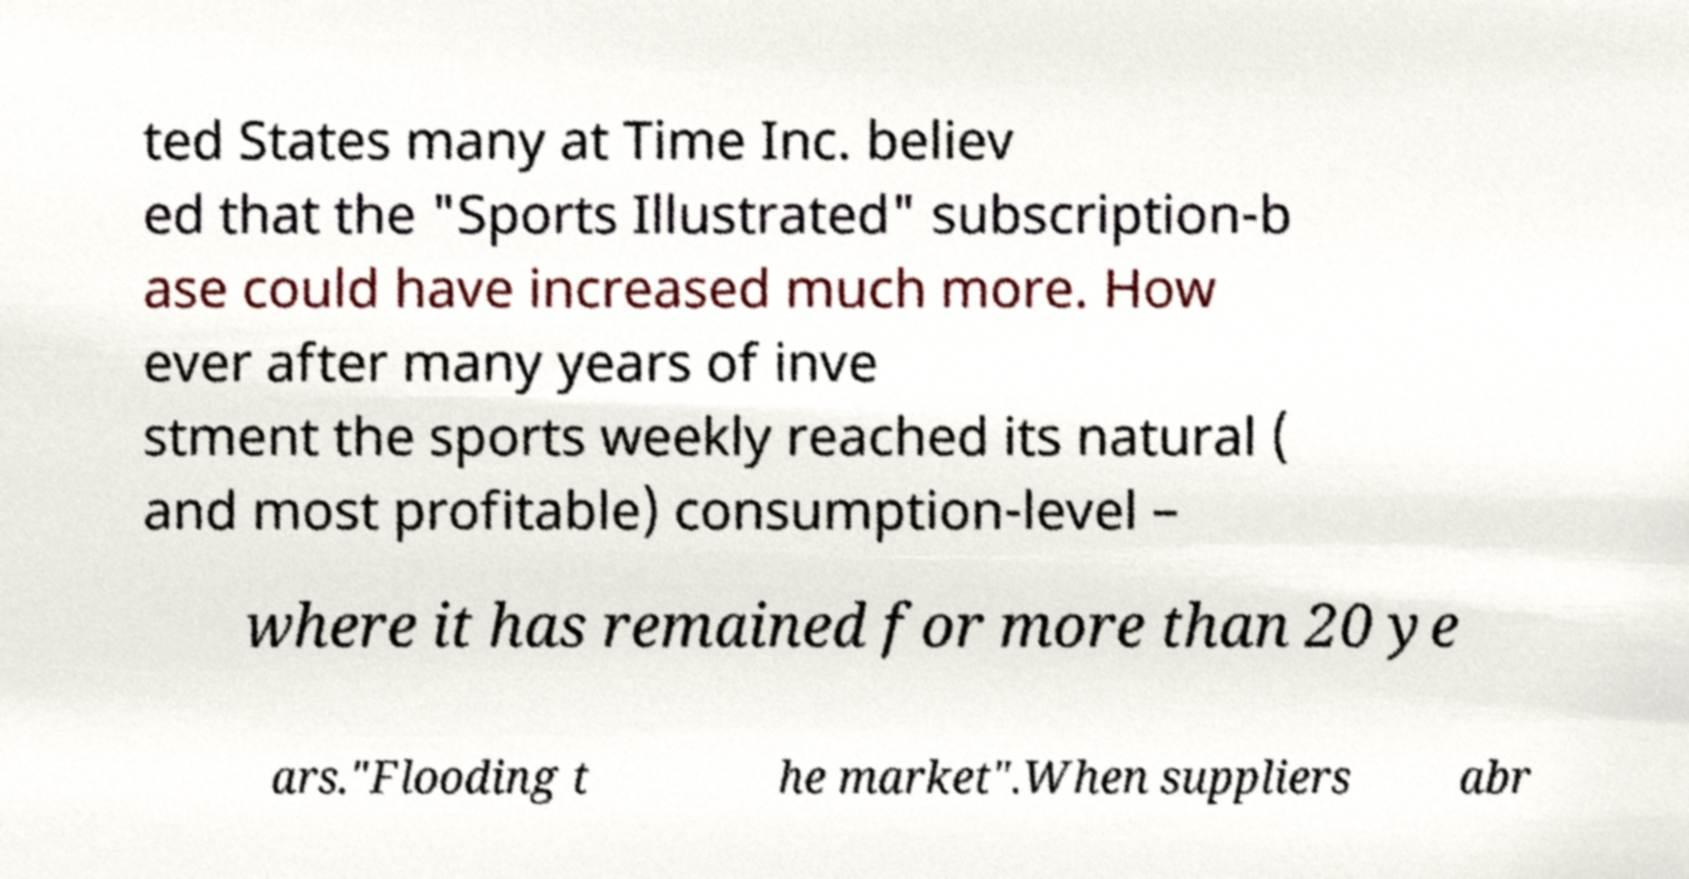Can you accurately transcribe the text from the provided image for me? ted States many at Time Inc. believ ed that the "Sports Illustrated" subscription-b ase could have increased much more. How ever after many years of inve stment the sports weekly reached its natural ( and most profitable) consumption-level – where it has remained for more than 20 ye ars."Flooding t he market".When suppliers abr 